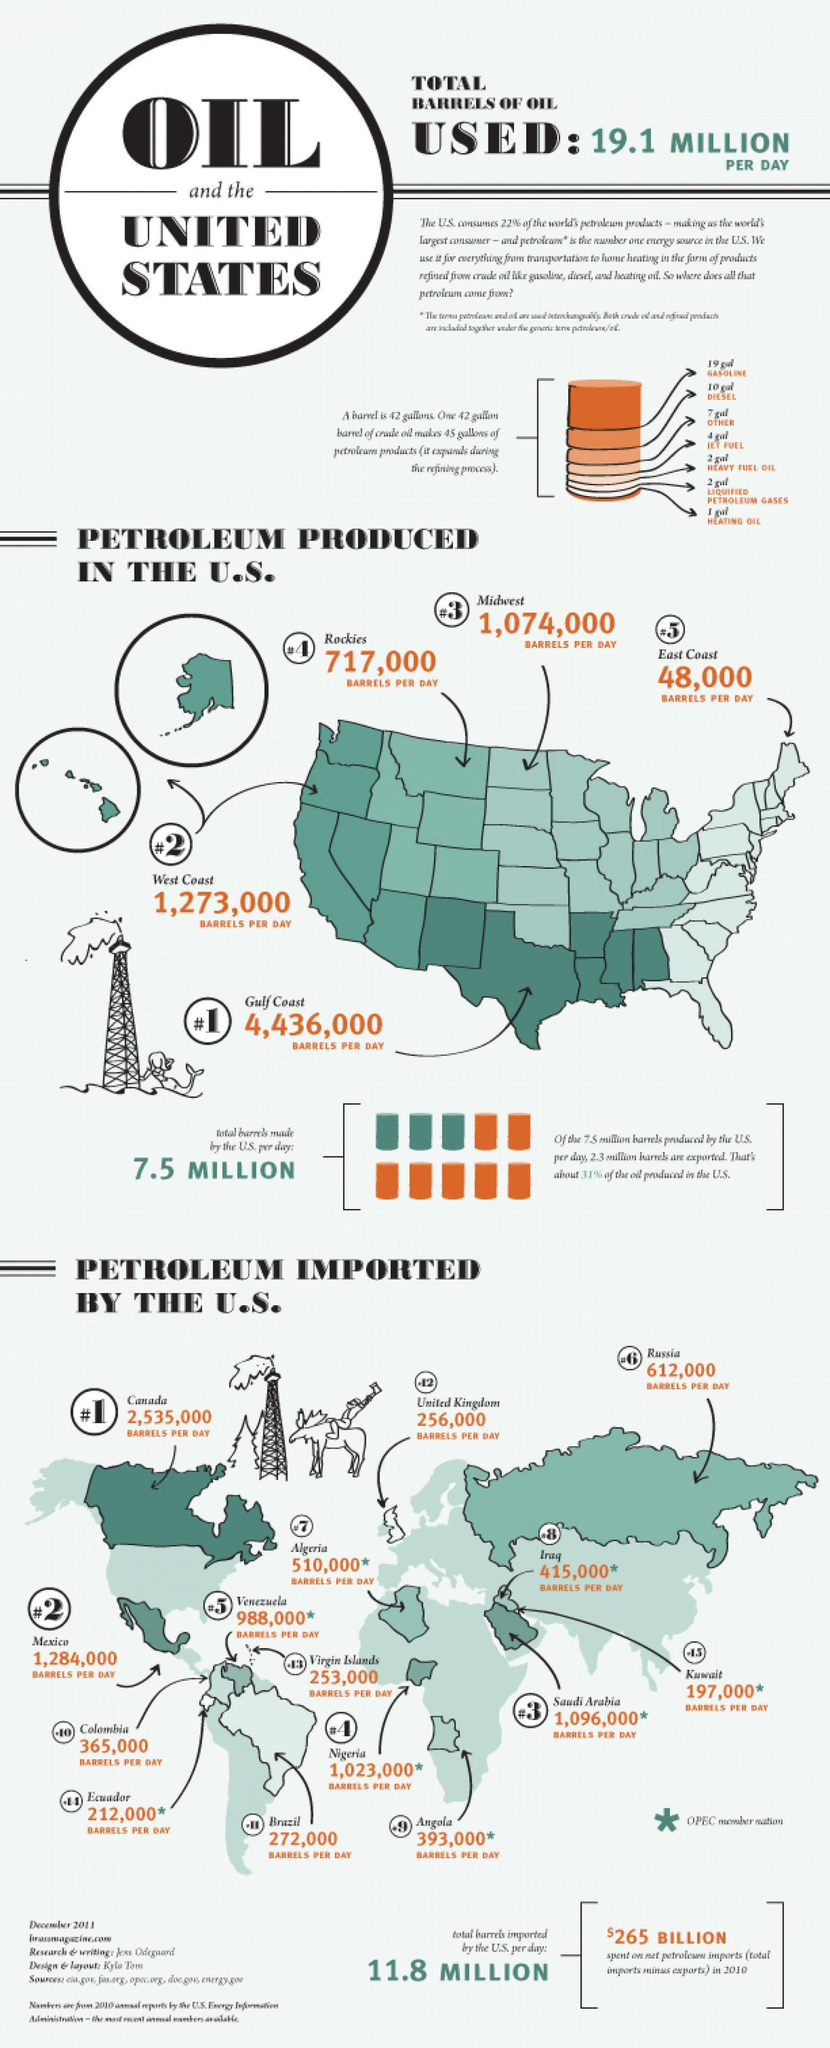What is total number of barrels exported to US per day from Canada, Mexico, and Saudi Arabia?
Answer the question with a short phrase. 4,915,000 What is the difference in barrels produced per day between West Coast and Midwest ? 199,000 What is the sum of total number of barrels imported by US and the number of barrels produced by the US? 19.3 million Which country is the second largest exporter of petroleum to the US? Mexico How many OPEC member nations export petroleum to the US? 8 How many countries export petroleum to the US? 13 Which region produces the maximum petroleum in the U.S., the Midwest, the Gulf Coast or the West Coast ? Gulf Coast What is the difference in the barrels produced per day between Rockies and East Coast ? 669,000 How much more barrels does the UK import to the US in comparison to Kuwait ? 59,000 Which Coast produces the lowest barrels per day,  Midwest, Rockies, or East Coast ? East Coast 